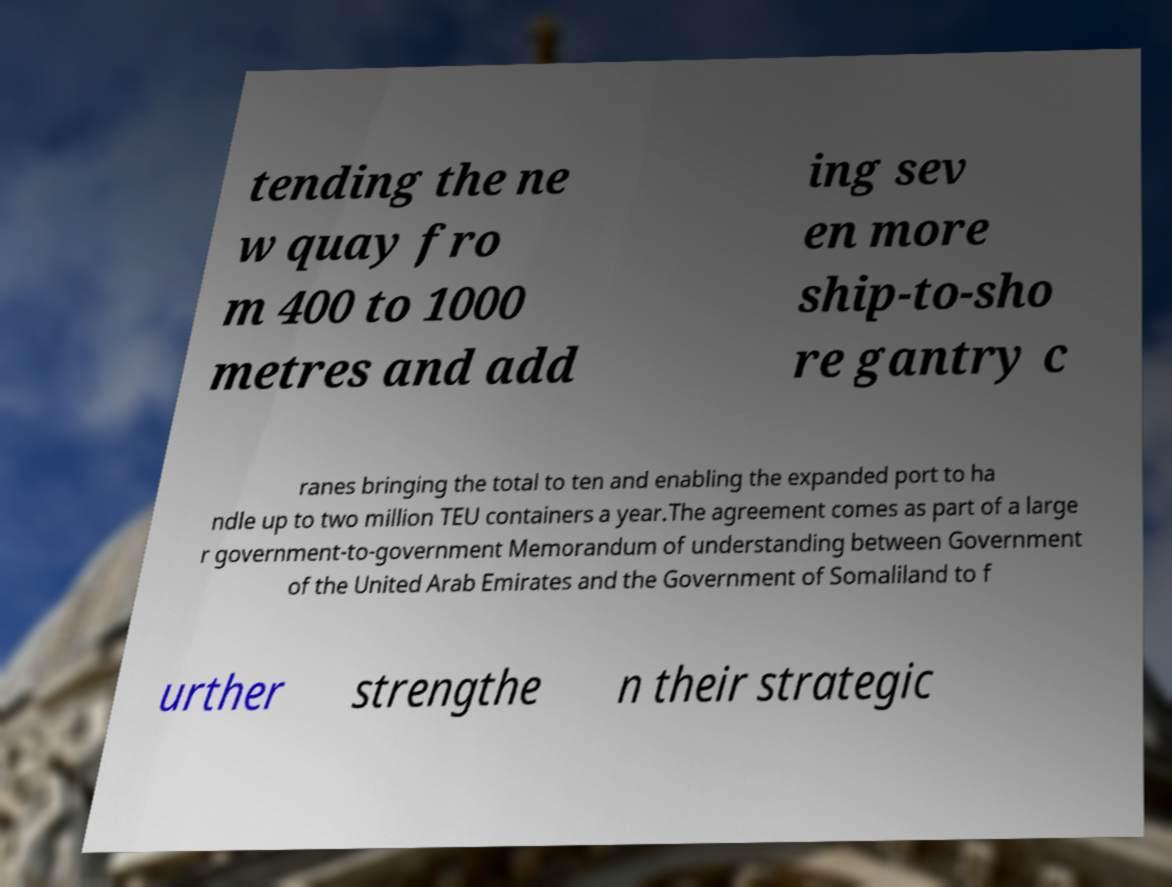Can you read and provide the text displayed in the image?This photo seems to have some interesting text. Can you extract and type it out for me? tending the ne w quay fro m 400 to 1000 metres and add ing sev en more ship-to-sho re gantry c ranes bringing the total to ten and enabling the expanded port to ha ndle up to two million TEU containers a year.The agreement comes as part of a large r government-to-government Memorandum of understanding between Government of the United Arab Emirates and the Government of Somaliland to f urther strengthe n their strategic 